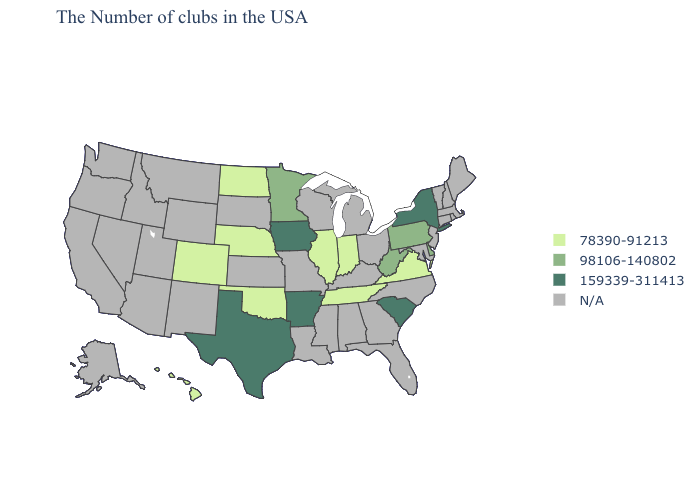Which states have the lowest value in the South?
Quick response, please. Virginia, Tennessee, Oklahoma. Which states have the lowest value in the USA?
Concise answer only. Virginia, Indiana, Tennessee, Illinois, Nebraska, Oklahoma, North Dakota, Colorado, Hawaii. Among the states that border West Virginia , does Virginia have the lowest value?
Be succinct. Yes. Does Arkansas have the highest value in the USA?
Short answer required. Yes. Does Arkansas have the highest value in the USA?
Give a very brief answer. Yes. What is the value of Delaware?
Keep it brief. 98106-140802. What is the value of New York?
Keep it brief. 159339-311413. Name the states that have a value in the range 78390-91213?
Concise answer only. Virginia, Indiana, Tennessee, Illinois, Nebraska, Oklahoma, North Dakota, Colorado, Hawaii. Does Pennsylvania have the highest value in the Northeast?
Write a very short answer. No. How many symbols are there in the legend?
Give a very brief answer. 4. What is the value of Hawaii?
Short answer required. 78390-91213. What is the value of Massachusetts?
Be succinct. N/A. Name the states that have a value in the range 159339-311413?
Concise answer only. New York, South Carolina, Arkansas, Iowa, Texas. 